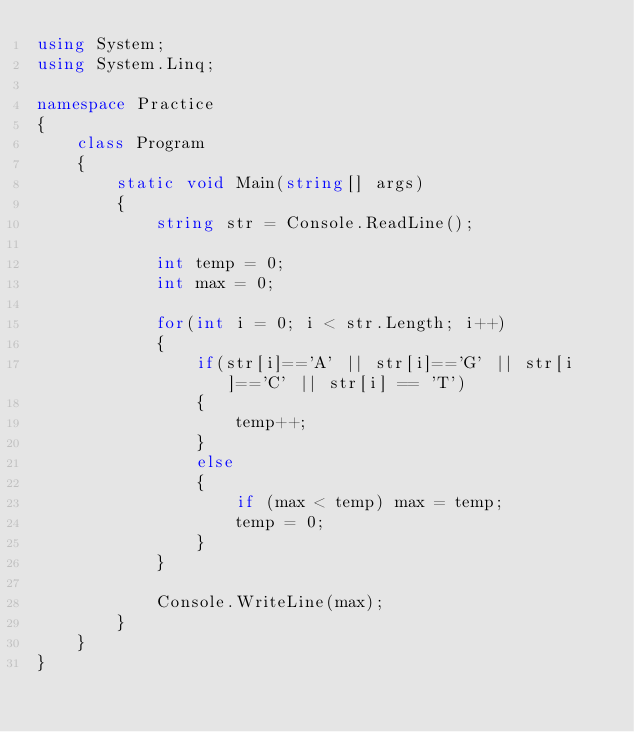<code> <loc_0><loc_0><loc_500><loc_500><_C#_>using System;
using System.Linq;

namespace Practice
{
    class Program
    {
        static void Main(string[] args)
        {
            string str = Console.ReadLine();

            int temp = 0;
            int max = 0;

            for(int i = 0; i < str.Length; i++)
            {
                if(str[i]=='A' || str[i]=='G' || str[i]=='C' || str[i] == 'T')
                {
                    temp++;
                }
                else
                {
                    if (max < temp) max = temp;
                    temp = 0;
                }
            }

            Console.WriteLine(max);
        }
    }
}
</code> 